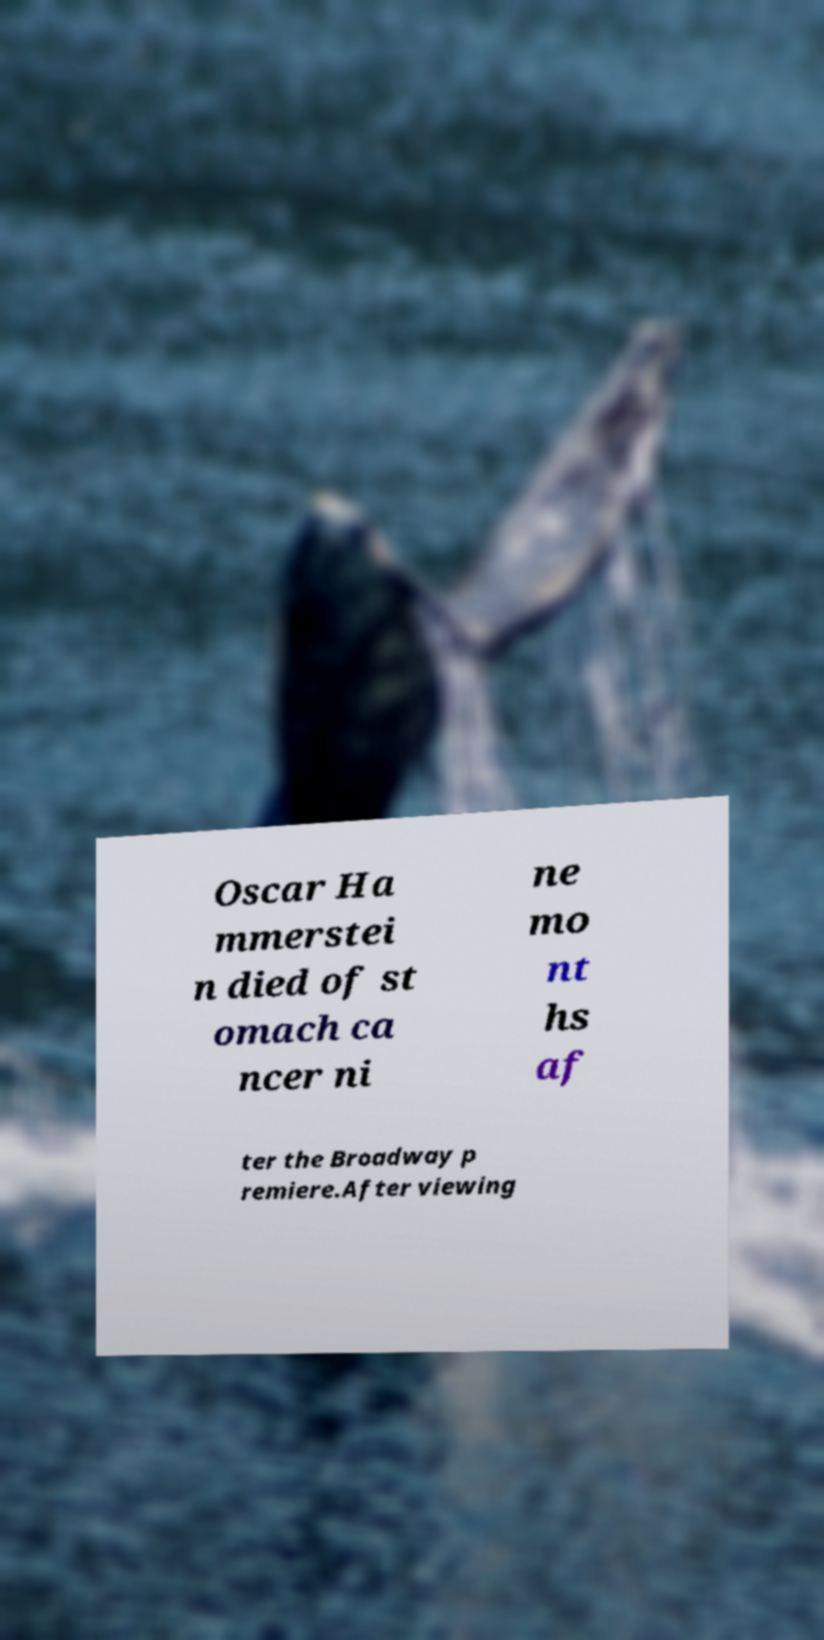For documentation purposes, I need the text within this image transcribed. Could you provide that? Oscar Ha mmerstei n died of st omach ca ncer ni ne mo nt hs af ter the Broadway p remiere.After viewing 